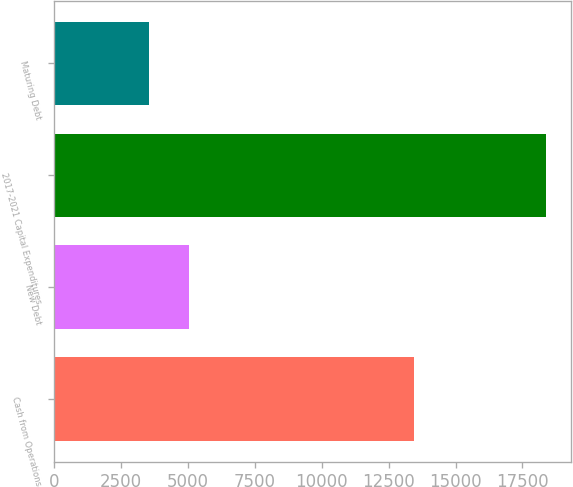Convert chart. <chart><loc_0><loc_0><loc_500><loc_500><bar_chart><fcel>Cash from Operations<fcel>New Debt<fcel>2017-2021 Capital Expenditures<fcel>Maturing Debt<nl><fcel>13465<fcel>5033.5<fcel>18385<fcel>3550<nl></chart> 